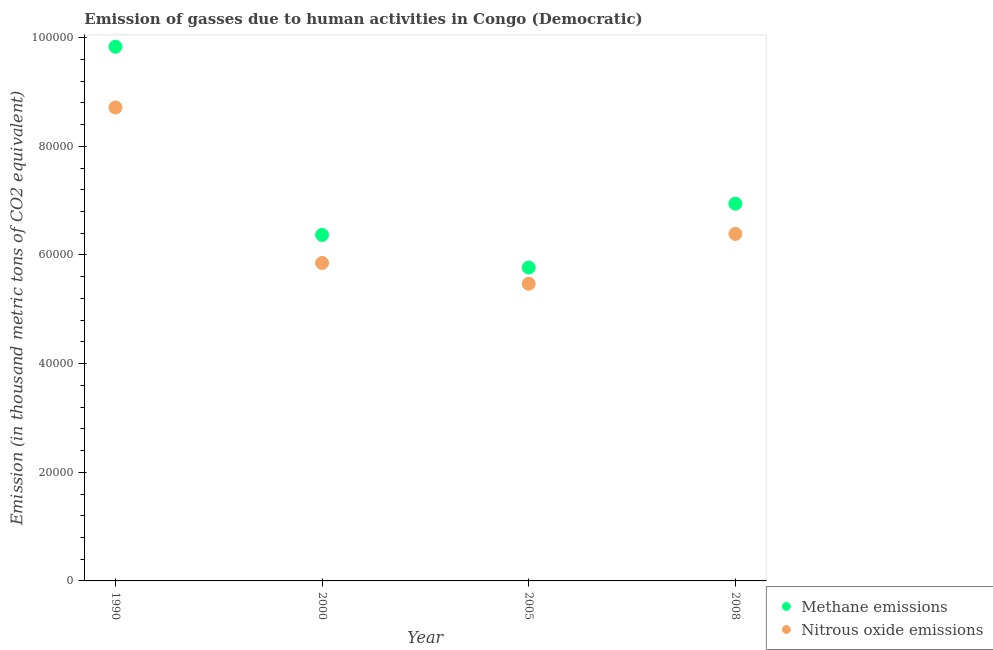How many different coloured dotlines are there?
Offer a terse response. 2. What is the amount of methane emissions in 1990?
Your answer should be compact. 9.83e+04. Across all years, what is the maximum amount of methane emissions?
Make the answer very short. 9.83e+04. Across all years, what is the minimum amount of methane emissions?
Your answer should be very brief. 5.77e+04. What is the total amount of nitrous oxide emissions in the graph?
Provide a succinct answer. 2.64e+05. What is the difference between the amount of nitrous oxide emissions in 1990 and that in 2000?
Ensure brevity in your answer.  2.86e+04. What is the difference between the amount of nitrous oxide emissions in 2000 and the amount of methane emissions in 2008?
Offer a terse response. -1.09e+04. What is the average amount of nitrous oxide emissions per year?
Your answer should be compact. 6.61e+04. In the year 1990, what is the difference between the amount of methane emissions and amount of nitrous oxide emissions?
Give a very brief answer. 1.12e+04. What is the ratio of the amount of nitrous oxide emissions in 1990 to that in 2005?
Provide a short and direct response. 1.59. What is the difference between the highest and the second highest amount of methane emissions?
Your response must be concise. 2.89e+04. What is the difference between the highest and the lowest amount of nitrous oxide emissions?
Offer a terse response. 3.25e+04. Is the sum of the amount of nitrous oxide emissions in 2005 and 2008 greater than the maximum amount of methane emissions across all years?
Your response must be concise. Yes. Does the amount of methane emissions monotonically increase over the years?
Ensure brevity in your answer.  No. Is the amount of nitrous oxide emissions strictly less than the amount of methane emissions over the years?
Ensure brevity in your answer.  Yes. How many years are there in the graph?
Your response must be concise. 4. What is the difference between two consecutive major ticks on the Y-axis?
Offer a very short reply. 2.00e+04. Does the graph contain grids?
Your response must be concise. No. Where does the legend appear in the graph?
Offer a very short reply. Bottom right. What is the title of the graph?
Make the answer very short. Emission of gasses due to human activities in Congo (Democratic). Does "Domestic liabilities" appear as one of the legend labels in the graph?
Ensure brevity in your answer.  No. What is the label or title of the X-axis?
Ensure brevity in your answer.  Year. What is the label or title of the Y-axis?
Your response must be concise. Emission (in thousand metric tons of CO2 equivalent). What is the Emission (in thousand metric tons of CO2 equivalent) in Methane emissions in 1990?
Offer a terse response. 9.83e+04. What is the Emission (in thousand metric tons of CO2 equivalent) in Nitrous oxide emissions in 1990?
Provide a short and direct response. 8.72e+04. What is the Emission (in thousand metric tons of CO2 equivalent) in Methane emissions in 2000?
Provide a short and direct response. 6.37e+04. What is the Emission (in thousand metric tons of CO2 equivalent) in Nitrous oxide emissions in 2000?
Ensure brevity in your answer.  5.85e+04. What is the Emission (in thousand metric tons of CO2 equivalent) in Methane emissions in 2005?
Offer a terse response. 5.77e+04. What is the Emission (in thousand metric tons of CO2 equivalent) of Nitrous oxide emissions in 2005?
Make the answer very short. 5.47e+04. What is the Emission (in thousand metric tons of CO2 equivalent) in Methane emissions in 2008?
Provide a short and direct response. 6.94e+04. What is the Emission (in thousand metric tons of CO2 equivalent) of Nitrous oxide emissions in 2008?
Your response must be concise. 6.39e+04. Across all years, what is the maximum Emission (in thousand metric tons of CO2 equivalent) in Methane emissions?
Offer a terse response. 9.83e+04. Across all years, what is the maximum Emission (in thousand metric tons of CO2 equivalent) of Nitrous oxide emissions?
Offer a very short reply. 8.72e+04. Across all years, what is the minimum Emission (in thousand metric tons of CO2 equivalent) of Methane emissions?
Make the answer very short. 5.77e+04. Across all years, what is the minimum Emission (in thousand metric tons of CO2 equivalent) of Nitrous oxide emissions?
Keep it short and to the point. 5.47e+04. What is the total Emission (in thousand metric tons of CO2 equivalent) of Methane emissions in the graph?
Make the answer very short. 2.89e+05. What is the total Emission (in thousand metric tons of CO2 equivalent) of Nitrous oxide emissions in the graph?
Provide a short and direct response. 2.64e+05. What is the difference between the Emission (in thousand metric tons of CO2 equivalent) in Methane emissions in 1990 and that in 2000?
Make the answer very short. 3.46e+04. What is the difference between the Emission (in thousand metric tons of CO2 equivalent) in Nitrous oxide emissions in 1990 and that in 2000?
Offer a terse response. 2.86e+04. What is the difference between the Emission (in thousand metric tons of CO2 equivalent) of Methane emissions in 1990 and that in 2005?
Your answer should be compact. 4.07e+04. What is the difference between the Emission (in thousand metric tons of CO2 equivalent) of Nitrous oxide emissions in 1990 and that in 2005?
Give a very brief answer. 3.25e+04. What is the difference between the Emission (in thousand metric tons of CO2 equivalent) of Methane emissions in 1990 and that in 2008?
Keep it short and to the point. 2.89e+04. What is the difference between the Emission (in thousand metric tons of CO2 equivalent) in Nitrous oxide emissions in 1990 and that in 2008?
Give a very brief answer. 2.33e+04. What is the difference between the Emission (in thousand metric tons of CO2 equivalent) in Methane emissions in 2000 and that in 2005?
Offer a terse response. 6010.4. What is the difference between the Emission (in thousand metric tons of CO2 equivalent) of Nitrous oxide emissions in 2000 and that in 2005?
Keep it short and to the point. 3826.5. What is the difference between the Emission (in thousand metric tons of CO2 equivalent) of Methane emissions in 2000 and that in 2008?
Offer a terse response. -5750.5. What is the difference between the Emission (in thousand metric tons of CO2 equivalent) in Nitrous oxide emissions in 2000 and that in 2008?
Ensure brevity in your answer.  -5353.8. What is the difference between the Emission (in thousand metric tons of CO2 equivalent) of Methane emissions in 2005 and that in 2008?
Ensure brevity in your answer.  -1.18e+04. What is the difference between the Emission (in thousand metric tons of CO2 equivalent) in Nitrous oxide emissions in 2005 and that in 2008?
Make the answer very short. -9180.3. What is the difference between the Emission (in thousand metric tons of CO2 equivalent) of Methane emissions in 1990 and the Emission (in thousand metric tons of CO2 equivalent) of Nitrous oxide emissions in 2000?
Make the answer very short. 3.98e+04. What is the difference between the Emission (in thousand metric tons of CO2 equivalent) of Methane emissions in 1990 and the Emission (in thousand metric tons of CO2 equivalent) of Nitrous oxide emissions in 2005?
Give a very brief answer. 4.36e+04. What is the difference between the Emission (in thousand metric tons of CO2 equivalent) in Methane emissions in 1990 and the Emission (in thousand metric tons of CO2 equivalent) in Nitrous oxide emissions in 2008?
Your response must be concise. 3.45e+04. What is the difference between the Emission (in thousand metric tons of CO2 equivalent) of Methane emissions in 2000 and the Emission (in thousand metric tons of CO2 equivalent) of Nitrous oxide emissions in 2005?
Your answer should be compact. 8993.6. What is the difference between the Emission (in thousand metric tons of CO2 equivalent) in Methane emissions in 2000 and the Emission (in thousand metric tons of CO2 equivalent) in Nitrous oxide emissions in 2008?
Your answer should be compact. -186.7. What is the difference between the Emission (in thousand metric tons of CO2 equivalent) of Methane emissions in 2005 and the Emission (in thousand metric tons of CO2 equivalent) of Nitrous oxide emissions in 2008?
Offer a very short reply. -6197.1. What is the average Emission (in thousand metric tons of CO2 equivalent) of Methane emissions per year?
Provide a short and direct response. 7.23e+04. What is the average Emission (in thousand metric tons of CO2 equivalent) of Nitrous oxide emissions per year?
Offer a terse response. 6.61e+04. In the year 1990, what is the difference between the Emission (in thousand metric tons of CO2 equivalent) of Methane emissions and Emission (in thousand metric tons of CO2 equivalent) of Nitrous oxide emissions?
Ensure brevity in your answer.  1.12e+04. In the year 2000, what is the difference between the Emission (in thousand metric tons of CO2 equivalent) of Methane emissions and Emission (in thousand metric tons of CO2 equivalent) of Nitrous oxide emissions?
Your answer should be compact. 5167.1. In the year 2005, what is the difference between the Emission (in thousand metric tons of CO2 equivalent) of Methane emissions and Emission (in thousand metric tons of CO2 equivalent) of Nitrous oxide emissions?
Provide a succinct answer. 2983.2. In the year 2008, what is the difference between the Emission (in thousand metric tons of CO2 equivalent) in Methane emissions and Emission (in thousand metric tons of CO2 equivalent) in Nitrous oxide emissions?
Your response must be concise. 5563.8. What is the ratio of the Emission (in thousand metric tons of CO2 equivalent) in Methane emissions in 1990 to that in 2000?
Provide a succinct answer. 1.54. What is the ratio of the Emission (in thousand metric tons of CO2 equivalent) in Nitrous oxide emissions in 1990 to that in 2000?
Your answer should be very brief. 1.49. What is the ratio of the Emission (in thousand metric tons of CO2 equivalent) in Methane emissions in 1990 to that in 2005?
Your answer should be very brief. 1.7. What is the ratio of the Emission (in thousand metric tons of CO2 equivalent) in Nitrous oxide emissions in 1990 to that in 2005?
Make the answer very short. 1.59. What is the ratio of the Emission (in thousand metric tons of CO2 equivalent) of Methane emissions in 1990 to that in 2008?
Keep it short and to the point. 1.42. What is the ratio of the Emission (in thousand metric tons of CO2 equivalent) of Nitrous oxide emissions in 1990 to that in 2008?
Provide a succinct answer. 1.36. What is the ratio of the Emission (in thousand metric tons of CO2 equivalent) in Methane emissions in 2000 to that in 2005?
Your answer should be very brief. 1.1. What is the ratio of the Emission (in thousand metric tons of CO2 equivalent) in Nitrous oxide emissions in 2000 to that in 2005?
Your answer should be compact. 1.07. What is the ratio of the Emission (in thousand metric tons of CO2 equivalent) of Methane emissions in 2000 to that in 2008?
Offer a terse response. 0.92. What is the ratio of the Emission (in thousand metric tons of CO2 equivalent) in Nitrous oxide emissions in 2000 to that in 2008?
Offer a terse response. 0.92. What is the ratio of the Emission (in thousand metric tons of CO2 equivalent) in Methane emissions in 2005 to that in 2008?
Provide a short and direct response. 0.83. What is the ratio of the Emission (in thousand metric tons of CO2 equivalent) of Nitrous oxide emissions in 2005 to that in 2008?
Provide a succinct answer. 0.86. What is the difference between the highest and the second highest Emission (in thousand metric tons of CO2 equivalent) in Methane emissions?
Keep it short and to the point. 2.89e+04. What is the difference between the highest and the second highest Emission (in thousand metric tons of CO2 equivalent) of Nitrous oxide emissions?
Your answer should be compact. 2.33e+04. What is the difference between the highest and the lowest Emission (in thousand metric tons of CO2 equivalent) in Methane emissions?
Give a very brief answer. 4.07e+04. What is the difference between the highest and the lowest Emission (in thousand metric tons of CO2 equivalent) of Nitrous oxide emissions?
Offer a terse response. 3.25e+04. 